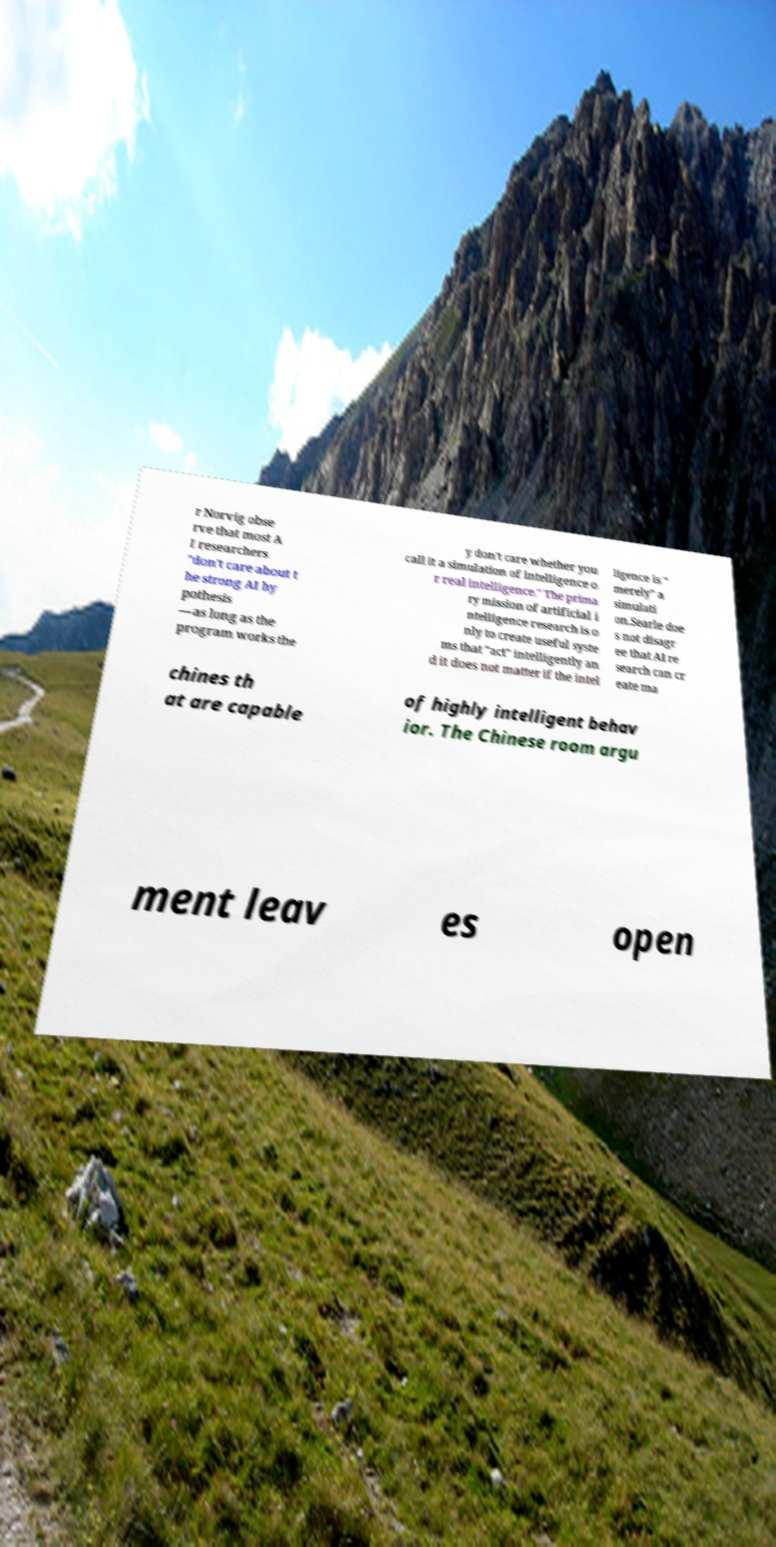For documentation purposes, I need the text within this image transcribed. Could you provide that? r Norvig obse rve that most A I researchers "don't care about t he strong AI hy pothesis —as long as the program works the y don't care whether you call it a simulation of intelligence o r real intelligence." The prima ry mission of artificial i ntelligence research is o nly to create useful syste ms that "act" intelligently an d it does not matter if the intel ligence is " merely" a simulati on.Searle doe s not disagr ee that AI re search can cr eate ma chines th at are capable of highly intelligent behav ior. The Chinese room argu ment leav es open 